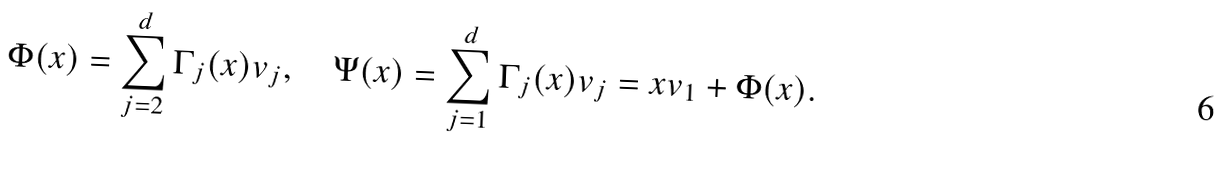Convert formula to latex. <formula><loc_0><loc_0><loc_500><loc_500>\Phi ( x ) = \sum _ { j = 2 } ^ { d } \Gamma _ { j } ( x ) v _ { j } , \quad \Psi ( x ) = \sum _ { j = 1 } ^ { d } \Gamma _ { j } ( x ) v _ { j } = x v _ { 1 } + \Phi ( x ) .</formula> 